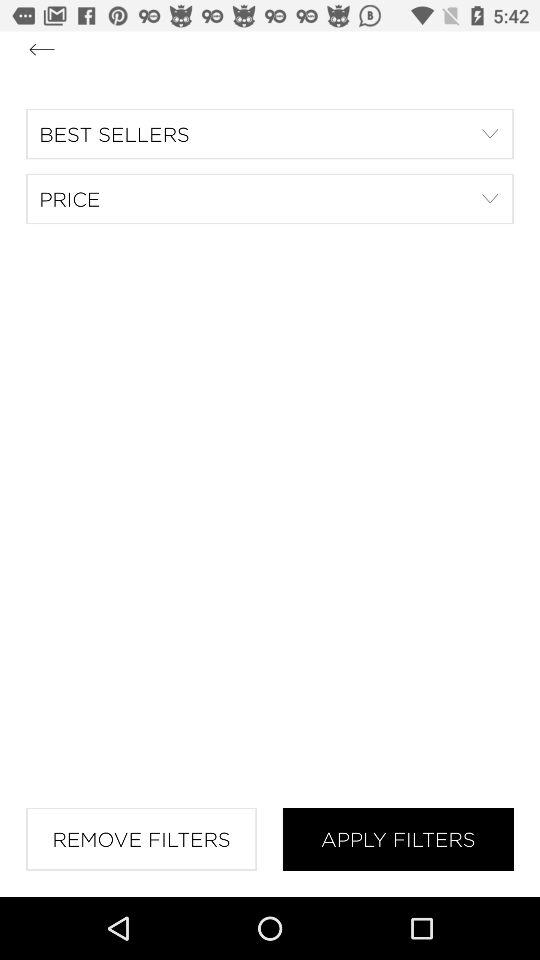How many more filters can I apply than remove?
Answer the question using a single word or phrase. 1 